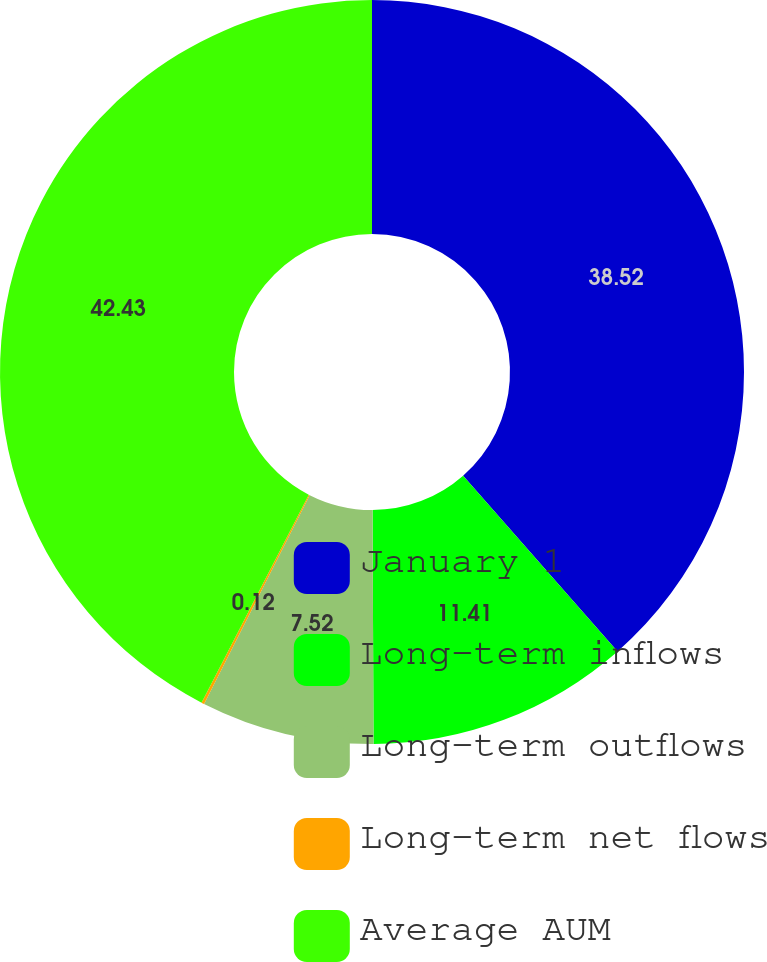<chart> <loc_0><loc_0><loc_500><loc_500><pie_chart><fcel>January 1<fcel>Long-term inflows<fcel>Long-term outflows<fcel>Long-term net flows<fcel>Average AUM<nl><fcel>38.52%<fcel>11.41%<fcel>7.52%<fcel>0.12%<fcel>42.42%<nl></chart> 